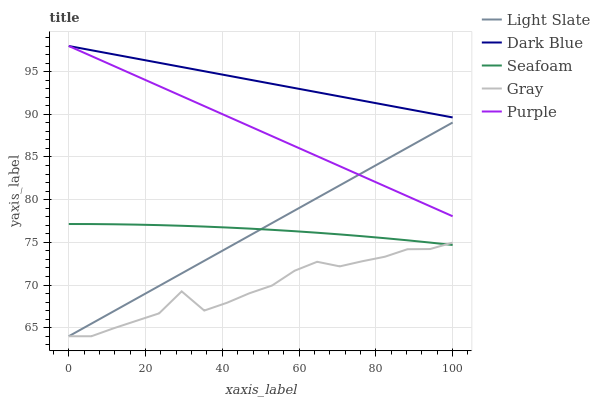Does Gray have the minimum area under the curve?
Answer yes or no. Yes. Does Dark Blue have the maximum area under the curve?
Answer yes or no. Yes. Does Seafoam have the minimum area under the curve?
Answer yes or no. No. Does Seafoam have the maximum area under the curve?
Answer yes or no. No. Is Dark Blue the smoothest?
Answer yes or no. Yes. Is Gray the roughest?
Answer yes or no. Yes. Is Seafoam the smoothest?
Answer yes or no. No. Is Seafoam the roughest?
Answer yes or no. No. Does Light Slate have the lowest value?
Answer yes or no. Yes. Does Seafoam have the lowest value?
Answer yes or no. No. Does Purple have the highest value?
Answer yes or no. Yes. Does Seafoam have the highest value?
Answer yes or no. No. Is Light Slate less than Dark Blue?
Answer yes or no. Yes. Is Dark Blue greater than Gray?
Answer yes or no. Yes. Does Seafoam intersect Gray?
Answer yes or no. Yes. Is Seafoam less than Gray?
Answer yes or no. No. Is Seafoam greater than Gray?
Answer yes or no. No. Does Light Slate intersect Dark Blue?
Answer yes or no. No. 